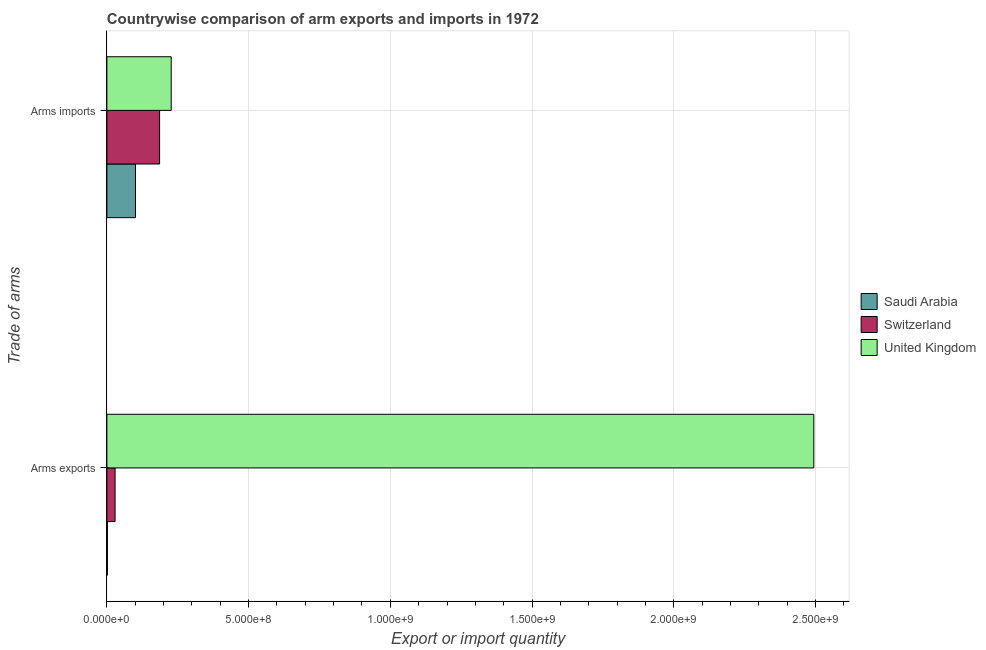How many different coloured bars are there?
Offer a very short reply. 3. How many groups of bars are there?
Provide a short and direct response. 2. Are the number of bars per tick equal to the number of legend labels?
Offer a terse response. Yes. Are the number of bars on each tick of the Y-axis equal?
Keep it short and to the point. Yes. How many bars are there on the 1st tick from the top?
Your answer should be compact. 3. What is the label of the 1st group of bars from the top?
Your answer should be compact. Arms imports. What is the arms imports in United Kingdom?
Your answer should be very brief. 2.27e+08. Across all countries, what is the maximum arms exports?
Offer a terse response. 2.49e+09. Across all countries, what is the minimum arms exports?
Give a very brief answer. 2.00e+06. In which country was the arms exports minimum?
Offer a terse response. Saudi Arabia. What is the total arms exports in the graph?
Give a very brief answer. 2.52e+09. What is the difference between the arms exports in Switzerland and that in Saudi Arabia?
Your answer should be compact. 2.70e+07. What is the difference between the arms imports in Switzerland and the arms exports in United Kingdom?
Provide a short and direct response. -2.31e+09. What is the average arms imports per country?
Your answer should be compact. 1.71e+08. What is the difference between the arms imports and arms exports in Switzerland?
Your response must be concise. 1.57e+08. In how many countries, is the arms imports greater than 500000000 ?
Your answer should be compact. 0. What does the 3rd bar from the top in Arms exports represents?
Offer a terse response. Saudi Arabia. What does the 1st bar from the bottom in Arms exports represents?
Provide a short and direct response. Saudi Arabia. Are the values on the major ticks of X-axis written in scientific E-notation?
Keep it short and to the point. Yes. How are the legend labels stacked?
Your answer should be very brief. Vertical. What is the title of the graph?
Offer a terse response. Countrywise comparison of arm exports and imports in 1972. What is the label or title of the X-axis?
Your answer should be compact. Export or import quantity. What is the label or title of the Y-axis?
Make the answer very short. Trade of arms. What is the Export or import quantity of Saudi Arabia in Arms exports?
Provide a short and direct response. 2.00e+06. What is the Export or import quantity of Switzerland in Arms exports?
Keep it short and to the point. 2.90e+07. What is the Export or import quantity of United Kingdom in Arms exports?
Your answer should be compact. 2.49e+09. What is the Export or import quantity of Saudi Arabia in Arms imports?
Provide a short and direct response. 1.01e+08. What is the Export or import quantity in Switzerland in Arms imports?
Ensure brevity in your answer.  1.86e+08. What is the Export or import quantity of United Kingdom in Arms imports?
Keep it short and to the point. 2.27e+08. Across all Trade of arms, what is the maximum Export or import quantity of Saudi Arabia?
Keep it short and to the point. 1.01e+08. Across all Trade of arms, what is the maximum Export or import quantity in Switzerland?
Provide a succinct answer. 1.86e+08. Across all Trade of arms, what is the maximum Export or import quantity of United Kingdom?
Your answer should be compact. 2.49e+09. Across all Trade of arms, what is the minimum Export or import quantity of Saudi Arabia?
Offer a terse response. 2.00e+06. Across all Trade of arms, what is the minimum Export or import quantity of Switzerland?
Your answer should be very brief. 2.90e+07. Across all Trade of arms, what is the minimum Export or import quantity of United Kingdom?
Give a very brief answer. 2.27e+08. What is the total Export or import quantity in Saudi Arabia in the graph?
Offer a terse response. 1.03e+08. What is the total Export or import quantity of Switzerland in the graph?
Your answer should be compact. 2.15e+08. What is the total Export or import quantity in United Kingdom in the graph?
Ensure brevity in your answer.  2.72e+09. What is the difference between the Export or import quantity in Saudi Arabia in Arms exports and that in Arms imports?
Provide a succinct answer. -9.90e+07. What is the difference between the Export or import quantity of Switzerland in Arms exports and that in Arms imports?
Provide a succinct answer. -1.57e+08. What is the difference between the Export or import quantity of United Kingdom in Arms exports and that in Arms imports?
Give a very brief answer. 2.27e+09. What is the difference between the Export or import quantity in Saudi Arabia in Arms exports and the Export or import quantity in Switzerland in Arms imports?
Give a very brief answer. -1.84e+08. What is the difference between the Export or import quantity in Saudi Arabia in Arms exports and the Export or import quantity in United Kingdom in Arms imports?
Provide a succinct answer. -2.25e+08. What is the difference between the Export or import quantity in Switzerland in Arms exports and the Export or import quantity in United Kingdom in Arms imports?
Your answer should be very brief. -1.98e+08. What is the average Export or import quantity of Saudi Arabia per Trade of arms?
Make the answer very short. 5.15e+07. What is the average Export or import quantity in Switzerland per Trade of arms?
Offer a terse response. 1.08e+08. What is the average Export or import quantity in United Kingdom per Trade of arms?
Give a very brief answer. 1.36e+09. What is the difference between the Export or import quantity in Saudi Arabia and Export or import quantity in Switzerland in Arms exports?
Offer a terse response. -2.70e+07. What is the difference between the Export or import quantity of Saudi Arabia and Export or import quantity of United Kingdom in Arms exports?
Give a very brief answer. -2.49e+09. What is the difference between the Export or import quantity of Switzerland and Export or import quantity of United Kingdom in Arms exports?
Offer a very short reply. -2.46e+09. What is the difference between the Export or import quantity in Saudi Arabia and Export or import quantity in Switzerland in Arms imports?
Offer a very short reply. -8.50e+07. What is the difference between the Export or import quantity of Saudi Arabia and Export or import quantity of United Kingdom in Arms imports?
Provide a succinct answer. -1.26e+08. What is the difference between the Export or import quantity in Switzerland and Export or import quantity in United Kingdom in Arms imports?
Your response must be concise. -4.10e+07. What is the ratio of the Export or import quantity of Saudi Arabia in Arms exports to that in Arms imports?
Make the answer very short. 0.02. What is the ratio of the Export or import quantity in Switzerland in Arms exports to that in Arms imports?
Keep it short and to the point. 0.16. What is the ratio of the Export or import quantity in United Kingdom in Arms exports to that in Arms imports?
Give a very brief answer. 10.99. What is the difference between the highest and the second highest Export or import quantity of Saudi Arabia?
Provide a succinct answer. 9.90e+07. What is the difference between the highest and the second highest Export or import quantity in Switzerland?
Provide a succinct answer. 1.57e+08. What is the difference between the highest and the second highest Export or import quantity of United Kingdom?
Offer a terse response. 2.27e+09. What is the difference between the highest and the lowest Export or import quantity of Saudi Arabia?
Provide a succinct answer. 9.90e+07. What is the difference between the highest and the lowest Export or import quantity of Switzerland?
Ensure brevity in your answer.  1.57e+08. What is the difference between the highest and the lowest Export or import quantity in United Kingdom?
Your response must be concise. 2.27e+09. 